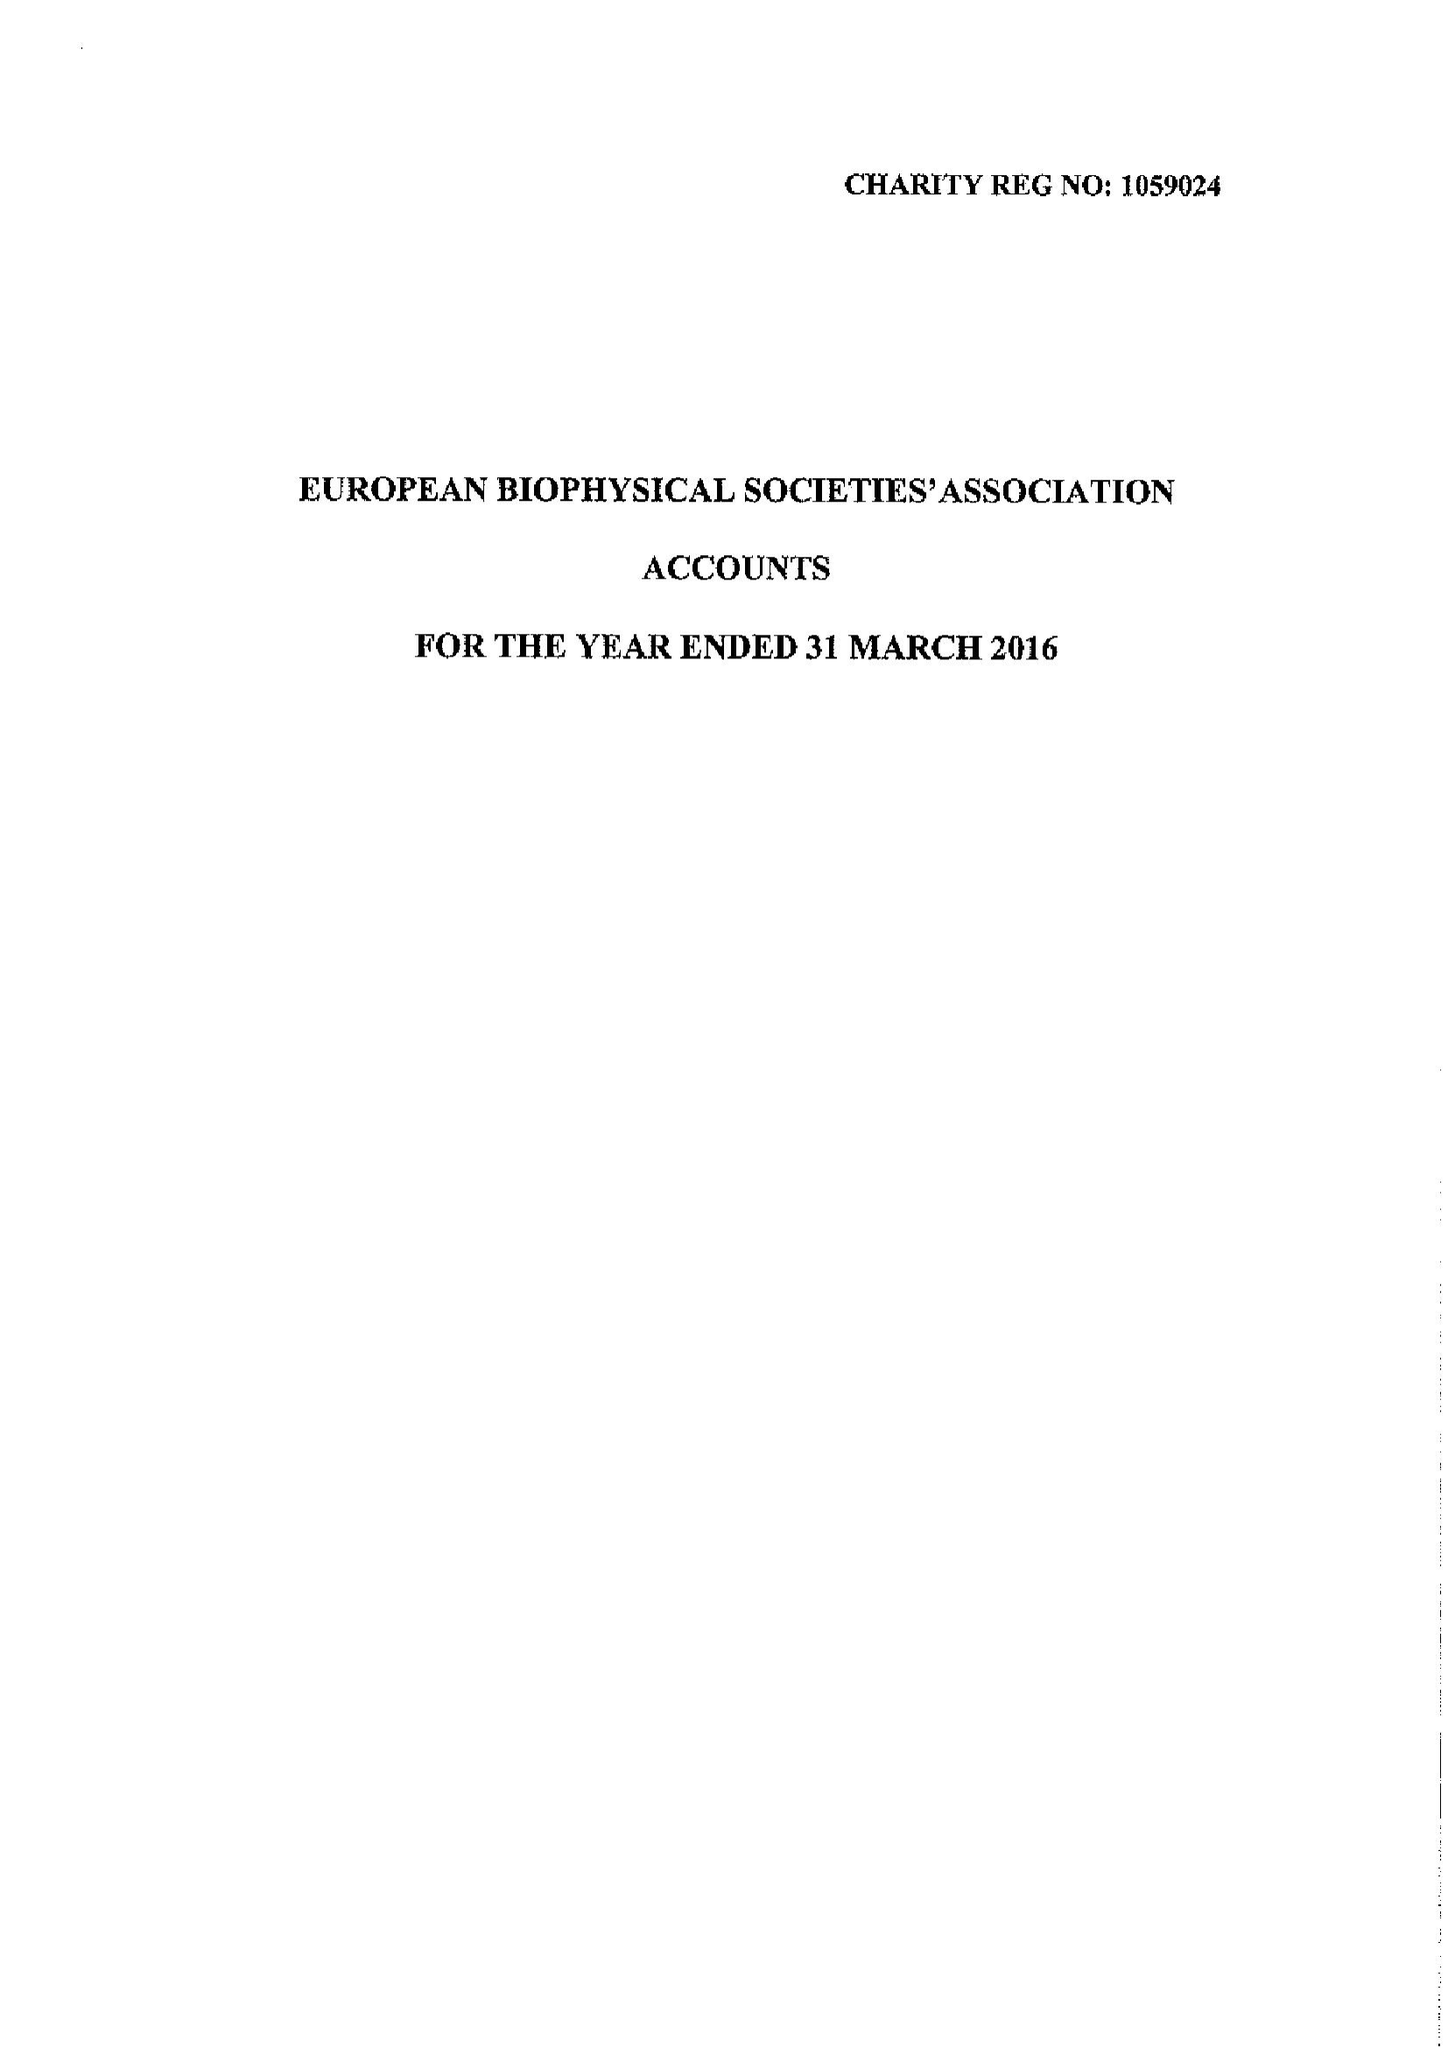What is the value for the address__post_town?
Answer the question using a single word or phrase. YORK 